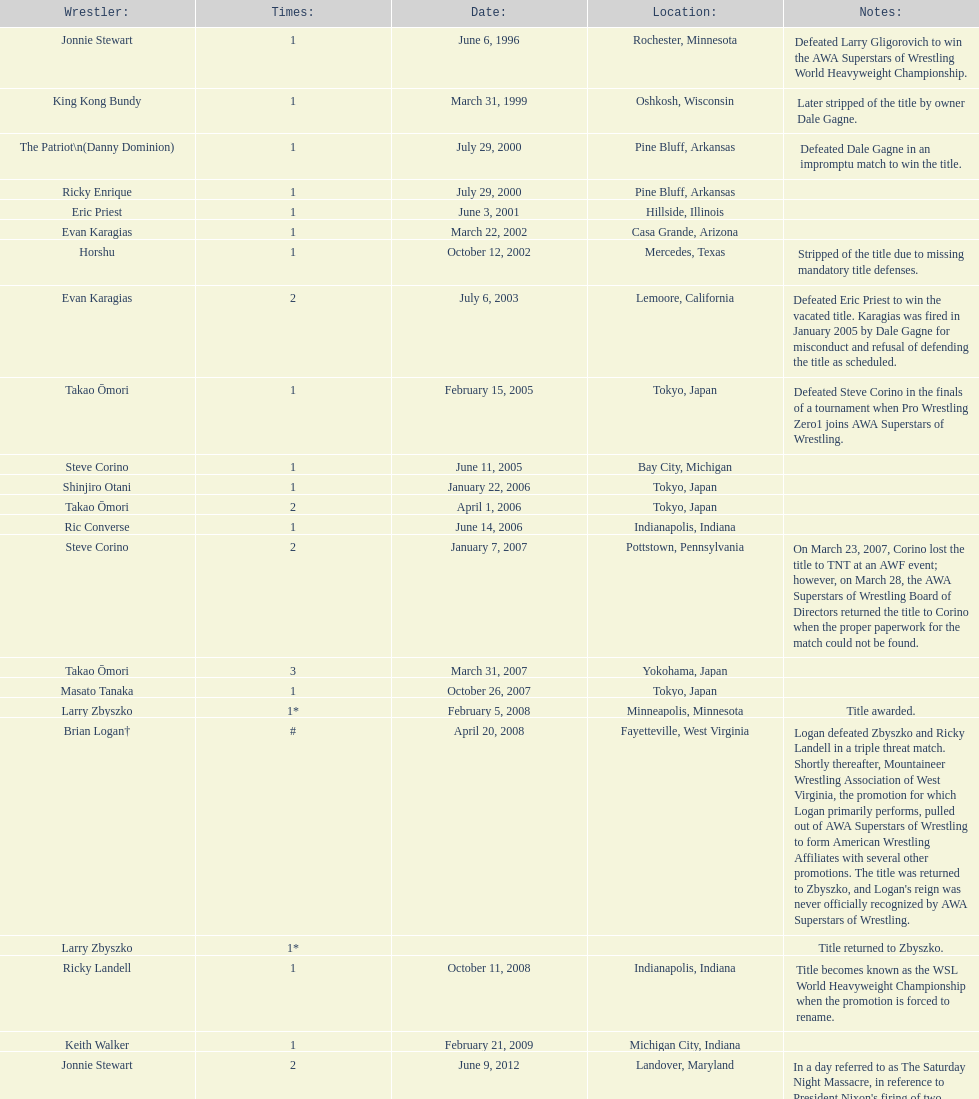When did steve corino win his first wsl title? June 11, 2005. Could you parse the entire table as a dict? {'header': ['Wrestler:', 'Times:', 'Date:', 'Location:', 'Notes:'], 'rows': [['Jonnie Stewart', '1', 'June 6, 1996', 'Rochester, Minnesota', 'Defeated Larry Gligorovich to win the AWA Superstars of Wrestling World Heavyweight Championship.'], ['King Kong Bundy', '1', 'March 31, 1999', 'Oshkosh, Wisconsin', 'Later stripped of the title by owner Dale Gagne.'], ['The Patriot\\n(Danny Dominion)', '1', 'July 29, 2000', 'Pine Bluff, Arkansas', 'Defeated Dale Gagne in an impromptu match to win the title.'], ['Ricky Enrique', '1', 'July 29, 2000', 'Pine Bluff, Arkansas', ''], ['Eric Priest', '1', 'June 3, 2001', 'Hillside, Illinois', ''], ['Evan Karagias', '1', 'March 22, 2002', 'Casa Grande, Arizona', ''], ['Horshu', '1', 'October 12, 2002', 'Mercedes, Texas', 'Stripped of the title due to missing mandatory title defenses.'], ['Evan Karagias', '2', 'July 6, 2003', 'Lemoore, California', 'Defeated Eric Priest to win the vacated title. Karagias was fired in January 2005 by Dale Gagne for misconduct and refusal of defending the title as scheduled.'], ['Takao Ōmori', '1', 'February 15, 2005', 'Tokyo, Japan', 'Defeated Steve Corino in the finals of a tournament when Pro Wrestling Zero1 joins AWA Superstars of Wrestling.'], ['Steve Corino', '1', 'June 11, 2005', 'Bay City, Michigan', ''], ['Shinjiro Otani', '1', 'January 22, 2006', 'Tokyo, Japan', ''], ['Takao Ōmori', '2', 'April 1, 2006', 'Tokyo, Japan', ''], ['Ric Converse', '1', 'June 14, 2006', 'Indianapolis, Indiana', ''], ['Steve Corino', '2', 'January 7, 2007', 'Pottstown, Pennsylvania', 'On March 23, 2007, Corino lost the title to TNT at an AWF event; however, on March 28, the AWA Superstars of Wrestling Board of Directors returned the title to Corino when the proper paperwork for the match could not be found.'], ['Takao Ōmori', '3', 'March 31, 2007', 'Yokohama, Japan', ''], ['Masato Tanaka', '1', 'October 26, 2007', 'Tokyo, Japan', ''], ['Larry Zbyszko', '1*', 'February 5, 2008', 'Minneapolis, Minnesota', 'Title awarded.'], ['Brian Logan†', '#', 'April 20, 2008', 'Fayetteville, West Virginia', "Logan defeated Zbyszko and Ricky Landell in a triple threat match. Shortly thereafter, Mountaineer Wrestling Association of West Virginia, the promotion for which Logan primarily performs, pulled out of AWA Superstars of Wrestling to form American Wrestling Affiliates with several other promotions. The title was returned to Zbyszko, and Logan's reign was never officially recognized by AWA Superstars of Wrestling."], ['Larry Zbyszko', '1*', '', '', 'Title returned to Zbyszko.'], ['Ricky Landell', '1', 'October 11, 2008', 'Indianapolis, Indiana', 'Title becomes known as the WSL World Heavyweight Championship when the promotion is forced to rename.'], ['Keith Walker', '1', 'February 21, 2009', 'Michigan City, Indiana', ''], ['Jonnie Stewart', '2', 'June 9, 2012', 'Landover, Maryland', "In a day referred to as The Saturday Night Massacre, in reference to President Nixon's firing of two Whitehouse attorneys general in one night; President Dale Gagne strips and fires Keith Walker when Walker refuses to defend the title against Ricky Landell, in an event in Landover, Maryland. When Landell is awarded the title, he refuses to accept and is too promptly fired by Gagne, who than awards the title to Jonnie Stewart."], ['The Honky Tonk Man', '1', 'August 18, 2012', 'Rockford, Illinois', "The morning of the event, Jonnie Stewart's doctors declare him PUP (physically unable to perform) and WSL officials agree to let Mike Bally sub for Stewart."]]} 